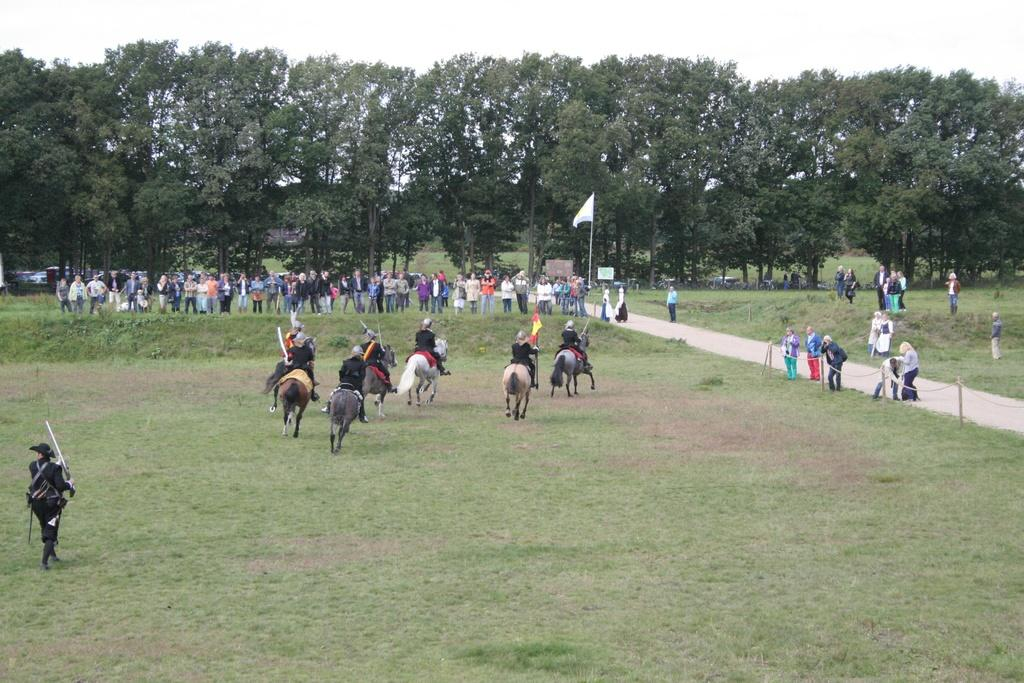What are the people in the image doing? The people in the image are sitting on horses. What is the terrain like in the image? The land is covered with grass. What can be seen in the background of the image? There is a flag, boards, people, trees, and the sky visible in the background. Who is holding the flag in the image? One person is holding a flag in the image. What type of pot is the father using to cook in the image? There is no father or pot present in the image; it features people sitting on horses with a flag and other background elements. Is the tramp performing any tricks on the horse in the image? There is no tramp or horse tricks present in the image; it simply shows people sitting on horses. 